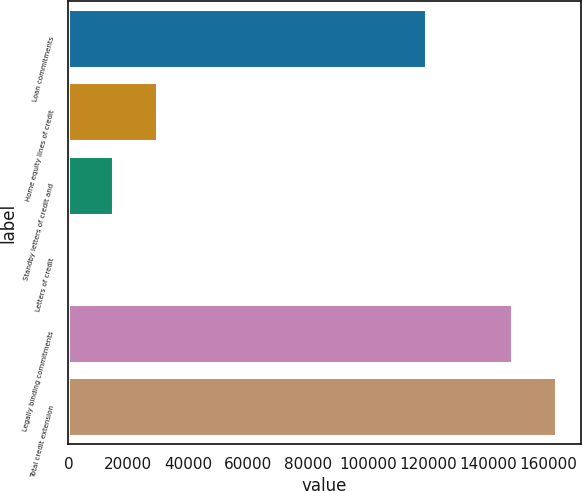<chart> <loc_0><loc_0><loc_500><loc_500><bar_chart><fcel>Loan commitments<fcel>Home equity lines of credit<fcel>Standby letters of credit and<fcel>Letters of credit<fcel>Legally binding commitments<fcel>Total credit extension<nl><fcel>119272<fcel>29687.6<fcel>14926.3<fcel>165<fcel>147778<fcel>162539<nl></chart> 